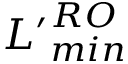Convert formula to latex. <formula><loc_0><loc_0><loc_500><loc_500>{ L ^ { \prime } } _ { \min } ^ { R O }</formula> 